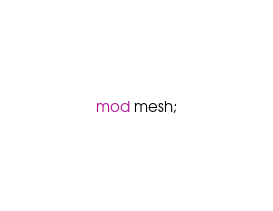Convert code to text. <code><loc_0><loc_0><loc_500><loc_500><_Rust_>mod mesh;


</code> 